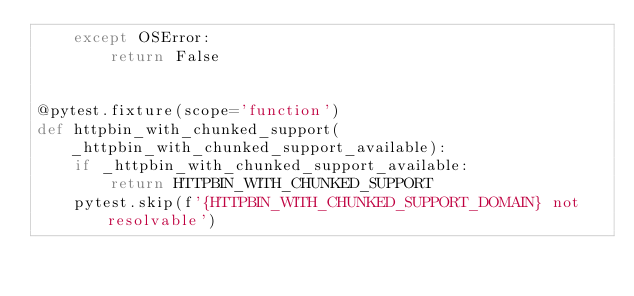<code> <loc_0><loc_0><loc_500><loc_500><_Python_>    except OSError:
        return False


@pytest.fixture(scope='function')
def httpbin_with_chunked_support(_httpbin_with_chunked_support_available):
    if _httpbin_with_chunked_support_available:
        return HTTPBIN_WITH_CHUNKED_SUPPORT
    pytest.skip(f'{HTTPBIN_WITH_CHUNKED_SUPPORT_DOMAIN} not resolvable')
</code> 